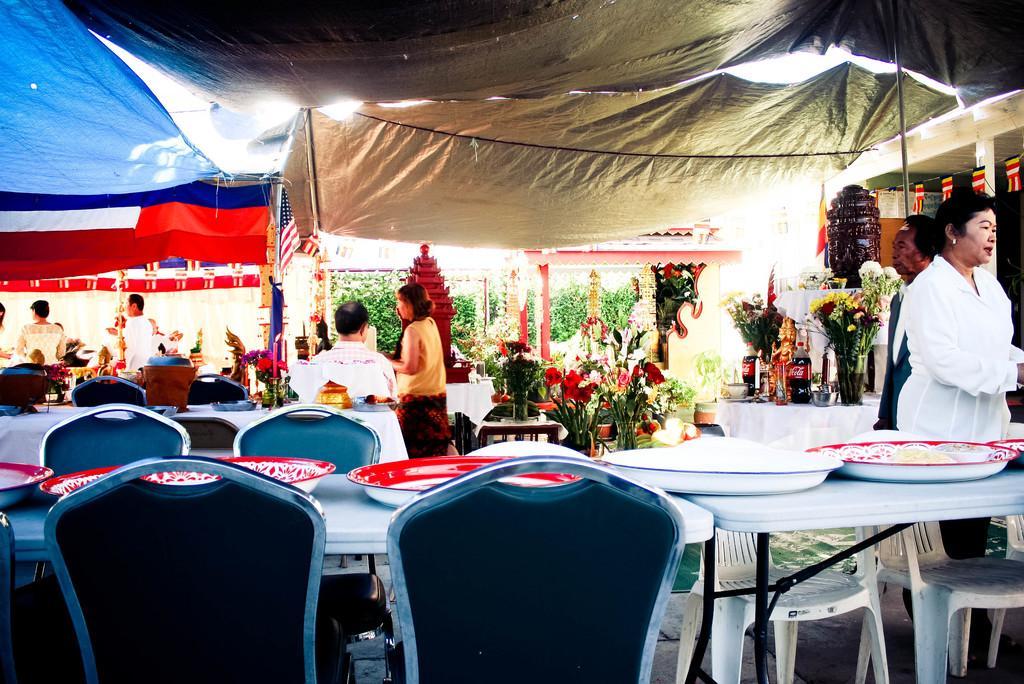Can you describe this image briefly? Most of the persons are standing. Here we can able to see number of chairs and tables. On this tables there are plates. Far there is a table with plants, bottle and bowl. These are plants. These are tents. This is an american flag. 